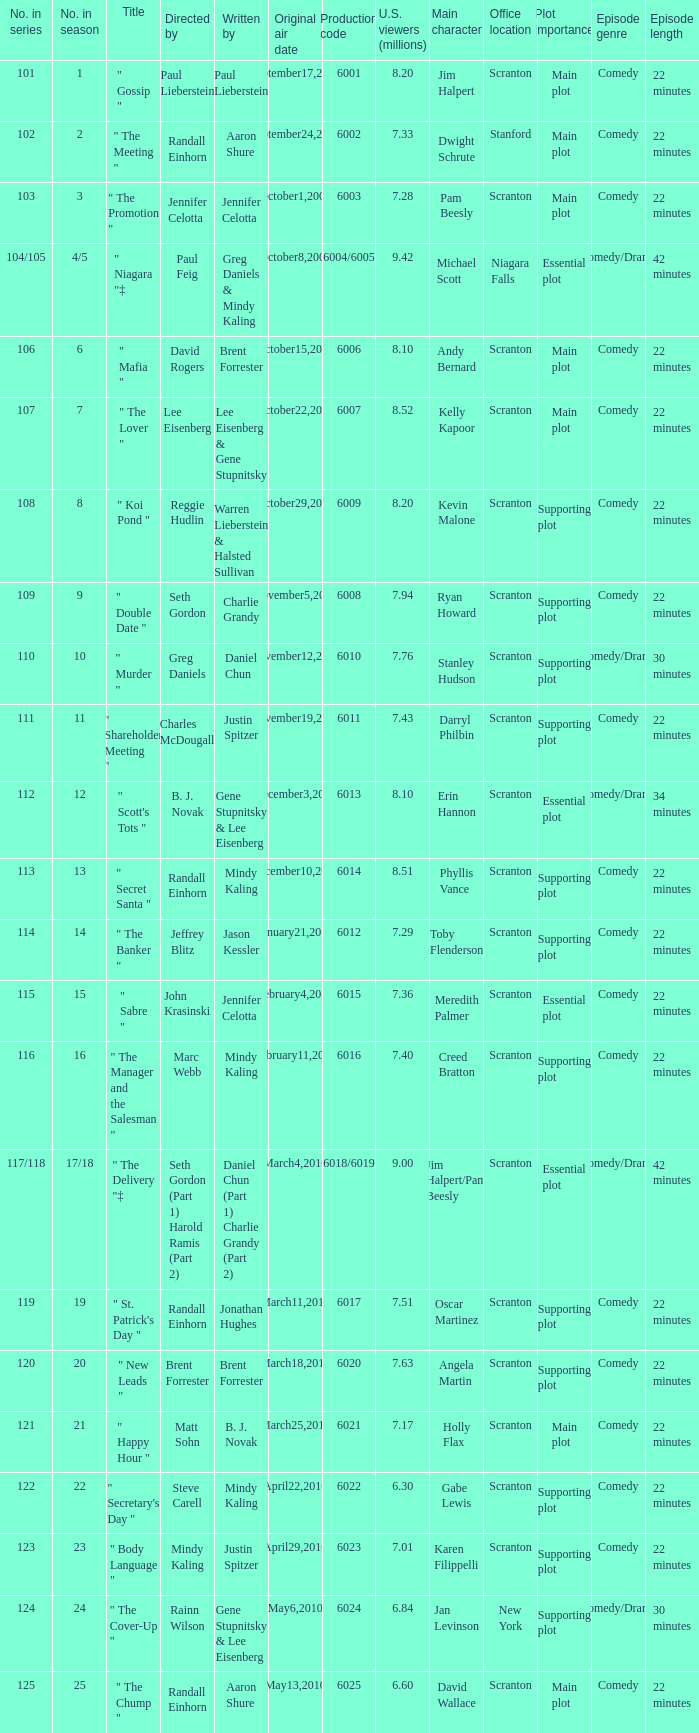Name the production code by paul lieberstein 6001.0. Parse the table in full. {'header': ['No. in series', 'No. in season', 'Title', 'Directed by', 'Written by', 'Original air date', 'Production code', 'U.S. viewers (millions)', 'Main character', 'Office location', 'Plot importance', 'Episode genre', 'Episode length'], 'rows': [['101', '1', '" Gossip "', 'Paul Lieberstein', 'Paul Lieberstein', 'September17,2009', '6001', '8.20', 'Jim Halpert', 'Scranton', 'Main plot', 'Comedy', '22 minutes'], ['102', '2', '" The Meeting "', 'Randall Einhorn', 'Aaron Shure', 'September24,2009', '6002', '7.33', 'Dwight Schrute', 'Stanford', 'Main plot', 'Comedy', '22 minutes'], ['103', '3', '" The Promotion "', 'Jennifer Celotta', 'Jennifer Celotta', 'October1,2009', '6003', '7.28', 'Pam Beesly', 'Scranton', 'Main plot', 'Comedy', '22 minutes'], ['104/105', '4/5', '" Niagara "‡', 'Paul Feig', 'Greg Daniels & Mindy Kaling', 'October8,2009', '6004/6005', '9.42', 'Michael Scott', 'Niagara Falls', 'Essential plot', 'Comedy/Drama', '42 minutes'], ['106', '6', '" Mafia "', 'David Rogers', 'Brent Forrester', 'October15,2009', '6006', '8.10', 'Andy Bernard', 'Scranton', 'Main plot', 'Comedy', '22 minutes'], ['107', '7', '" The Lover "', 'Lee Eisenberg', 'Lee Eisenberg & Gene Stupnitsky', 'October22,2009', '6007', '8.52', 'Kelly Kapoor', 'Scranton', 'Main plot', 'Comedy', '22 minutes'], ['108', '8', '" Koi Pond "', 'Reggie Hudlin', 'Warren Lieberstein & Halsted Sullivan', 'October29,2009', '6009', '8.20', 'Kevin Malone', 'Scranton', 'Supporting plot', 'Comedy', '22 minutes'], ['109', '9', '" Double Date "', 'Seth Gordon', 'Charlie Grandy', 'November5,2009', '6008', '7.94', 'Ryan Howard', 'Scranton', 'Supporting plot', 'Comedy', '22 minutes'], ['110', '10', '" Murder "', 'Greg Daniels', 'Daniel Chun', 'November12,2009', '6010', '7.76', 'Stanley Hudson', 'Scranton', 'Supporting plot', 'Comedy/Drama', '30 minutes'], ['111', '11', '" Shareholder Meeting "', 'Charles McDougall', 'Justin Spitzer', 'November19,2009', '6011', '7.43', 'Darryl Philbin', 'Scranton', 'Supporting plot', 'Comedy', '22 minutes'], ['112', '12', '" Scott\'s Tots "', 'B. J. Novak', 'Gene Stupnitsky & Lee Eisenberg', 'December3,2009', '6013', '8.10', 'Erin Hannon', 'Scranton', 'Essential plot', 'Comedy/Drama', '34 minutes'], ['113', '13', '" Secret Santa "', 'Randall Einhorn', 'Mindy Kaling', 'December10,2009', '6014', '8.51', 'Phyllis Vance', 'Scranton', 'Supporting plot', 'Comedy', '22 minutes'], ['114', '14', '" The Banker "', 'Jeffrey Blitz', 'Jason Kessler', 'January21,2010', '6012', '7.29', 'Toby Flenderson', 'Scranton', 'Supporting plot', 'Comedy', '22 minutes'], ['115', '15', '" Sabre "', 'John Krasinski', 'Jennifer Celotta', 'February4,2010', '6015', '7.36', 'Meredith Palmer', 'Scranton', 'Essential plot', 'Comedy', '22 minutes'], ['116', '16', '" The Manager and the Salesman "', 'Marc Webb', 'Mindy Kaling', 'February11,2010', '6016', '7.40', 'Creed Bratton', 'Scranton', 'Supporting plot', 'Comedy', '22 minutes'], ['117/118', '17/18', '" The Delivery "‡', 'Seth Gordon (Part 1) Harold Ramis (Part 2)', 'Daniel Chun (Part 1) Charlie Grandy (Part 2)', 'March4,2010', '6018/6019', '9.00', 'Jim Halpert/Pam Beesly', 'Scranton', 'Essential plot', 'Comedy/Drama', '42 minutes'], ['119', '19', '" St. Patrick\'s Day "', 'Randall Einhorn', 'Jonathan Hughes', 'March11,2010', '6017', '7.51', 'Oscar Martinez', 'Scranton', 'Supporting plot', 'Comedy', '22 minutes'], ['120', '20', '" New Leads "', 'Brent Forrester', 'Brent Forrester', 'March18,2010', '6020', '7.63', 'Angela Martin', 'Scranton', 'Supporting plot', 'Comedy', '22 minutes'], ['121', '21', '" Happy Hour "', 'Matt Sohn', 'B. J. Novak', 'March25,2010', '6021', '7.17', 'Holly Flax', 'Scranton', 'Main plot', 'Comedy', '22 minutes'], ['122', '22', '" Secretary\'s Day "', 'Steve Carell', 'Mindy Kaling', 'April22,2010', '6022', '6.30', 'Gabe Lewis', 'Scranton', 'Supporting plot', 'Comedy', '22 minutes'], ['123', '23', '" Body Language "', 'Mindy Kaling', 'Justin Spitzer', 'April29,2010', '6023', '7.01', 'Karen Filippelli', 'Scranton', 'Supporting plot', 'Comedy', '22 minutes'], ['124', '24', '" The Cover-Up "', 'Rainn Wilson', 'Gene Stupnitsky & Lee Eisenberg', 'May6,2010', '6024', '6.84', 'Jan Levinson', 'New York', 'Supporting plot', 'Comedy/Drama', '30 minutes'], ['125', '25', '" The Chump "', 'Randall Einhorn', 'Aaron Shure', 'May13,2010', '6025', '6.60', 'David Wallace', 'Scranton', 'Main plot', 'Comedy', '22 minutes']]} 